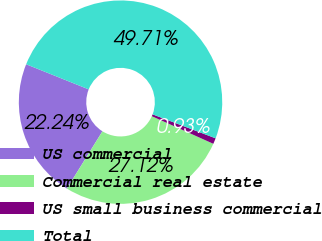Convert chart to OTSL. <chart><loc_0><loc_0><loc_500><loc_500><pie_chart><fcel>US commercial<fcel>Commercial real estate<fcel>US small business commercial<fcel>Total<nl><fcel>22.24%<fcel>27.12%<fcel>0.93%<fcel>49.71%<nl></chart> 